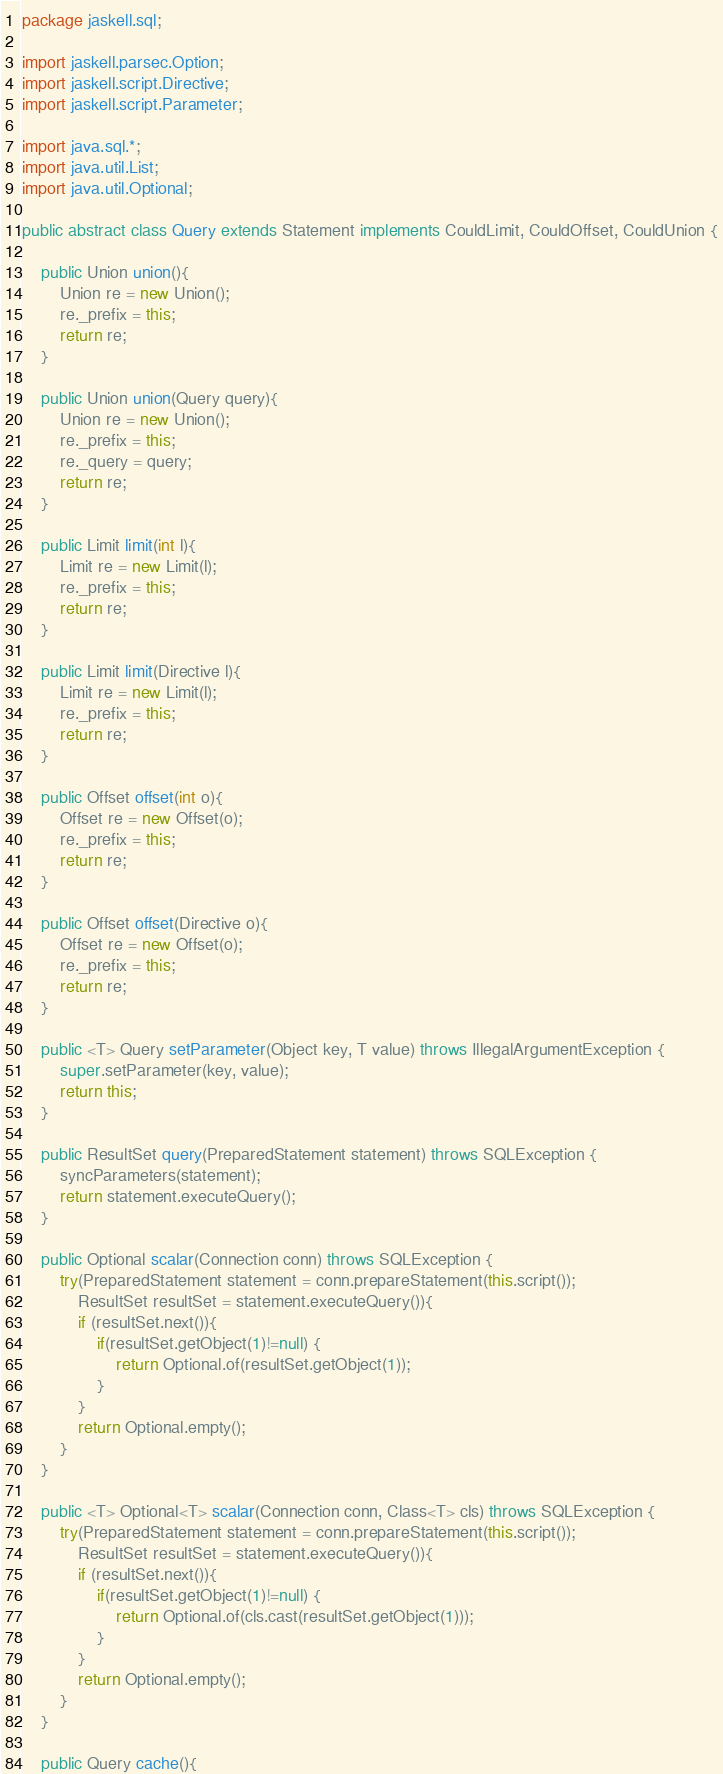Convert code to text. <code><loc_0><loc_0><loc_500><loc_500><_Java_>package jaskell.sql;

import jaskell.parsec.Option;
import jaskell.script.Directive;
import jaskell.script.Parameter;

import java.sql.*;
import java.util.List;
import java.util.Optional;

public abstract class Query extends Statement implements CouldLimit, CouldOffset, CouldUnion {

    public Union union(){
        Union re = new Union();
        re._prefix = this;
        return re;
    }

    public Union union(Query query){
        Union re = new Union();
        re._prefix = this;
        re._query = query;
        return re;
    }

    public Limit limit(int l){
        Limit re = new Limit(l);
        re._prefix = this;
        return re;
    }

    public Limit limit(Directive l){
        Limit re = new Limit(l);
        re._prefix = this;
        return re;
    }

    public Offset offset(int o){
        Offset re = new Offset(o);
        re._prefix = this;
        return re;
    }

    public Offset offset(Directive o){
        Offset re = new Offset(o);
        re._prefix = this;
        return re;
    }

    public <T> Query setParameter(Object key, T value) throws IllegalArgumentException {
        super.setParameter(key, value);
        return this;
    }

    public ResultSet query(PreparedStatement statement) throws SQLException {
        syncParameters(statement);
        return statement.executeQuery();
    }

    public Optional scalar(Connection conn) throws SQLException {
        try(PreparedStatement statement = conn.prepareStatement(this.script());
            ResultSet resultSet = statement.executeQuery()){
            if (resultSet.next()){
                if(resultSet.getObject(1)!=null) {
                    return Optional.of(resultSet.getObject(1));
                }
            }
            return Optional.empty();
        }
    }

    public <T> Optional<T> scalar(Connection conn, Class<T> cls) throws SQLException {
        try(PreparedStatement statement = conn.prepareStatement(this.script());
            ResultSet resultSet = statement.executeQuery()){
            if (resultSet.next()){
                if(resultSet.getObject(1)!=null) {
                    return Optional.of(cls.cast(resultSet.getObject(1)));
                }
            }
            return Optional.empty();
        }
    }

    public Query cache(){</code> 